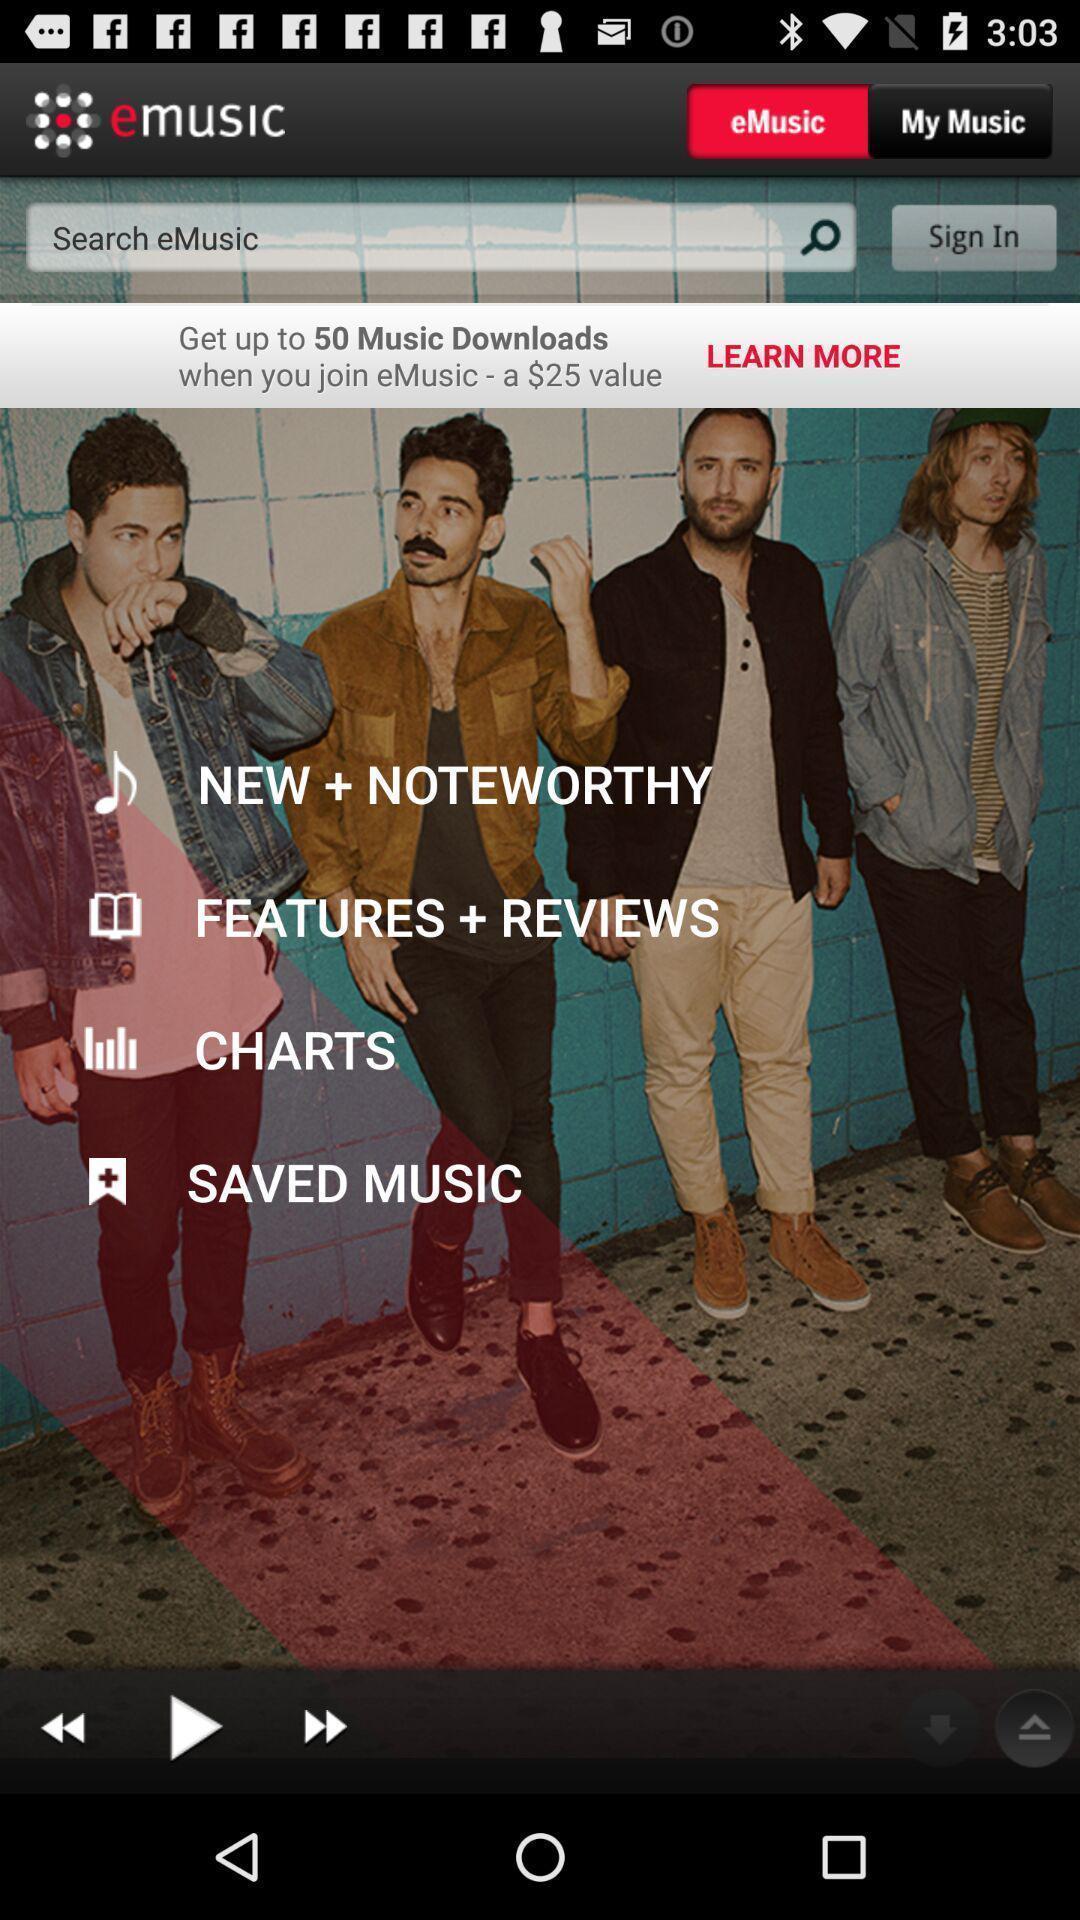Tell me what you see in this picture. Page showing search option to search music. 